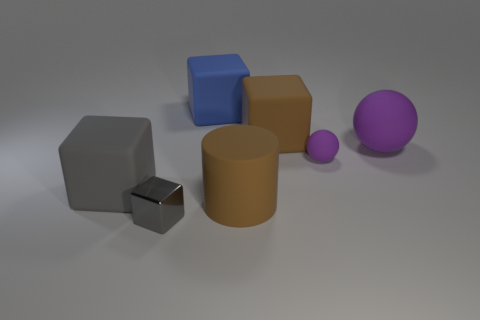Are there any other things that have the same material as the tiny block?
Make the answer very short. No. Are there more rubber blocks right of the gray shiny block than brown cylinders?
Your answer should be very brief. Yes. Is the number of blue cubes in front of the small matte ball the same as the number of cylinders that are in front of the big gray matte object?
Your response must be concise. No. There is a gray thing that is on the left side of the small gray metal cube; are there any matte things that are behind it?
Your response must be concise. Yes. The large blue rubber thing is what shape?
Provide a short and direct response. Cube. What size is the other matte ball that is the same color as the large matte ball?
Keep it short and to the point. Small. What is the size of the gray block that is in front of the large matte block that is on the left side of the blue rubber cube?
Keep it short and to the point. Small. What is the size of the metallic thing that is in front of the big blue block?
Make the answer very short. Small. Are there fewer big matte spheres that are to the left of the large blue matte thing than things in front of the big brown matte cube?
Your answer should be very brief. Yes. What is the color of the tiny matte object?
Make the answer very short. Purple. 